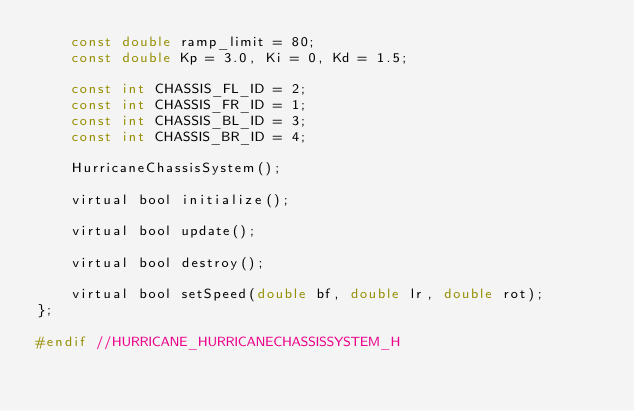Convert code to text. <code><loc_0><loc_0><loc_500><loc_500><_C_>    const double ramp_limit = 80;
    const double Kp = 3.0, Ki = 0, Kd = 1.5;

    const int CHASSIS_FL_ID = 2;
    const int CHASSIS_FR_ID = 1;
    const int CHASSIS_BL_ID = 3;
    const int CHASSIS_BR_ID = 4;

    HurricaneChassisSystem();

    virtual bool initialize();

    virtual bool update();

    virtual bool destroy();

    virtual bool setSpeed(double bf, double lr, double rot);
};

#endif //HURRICANE_HURRICANECHASSISSYSTEM_H
</code> 